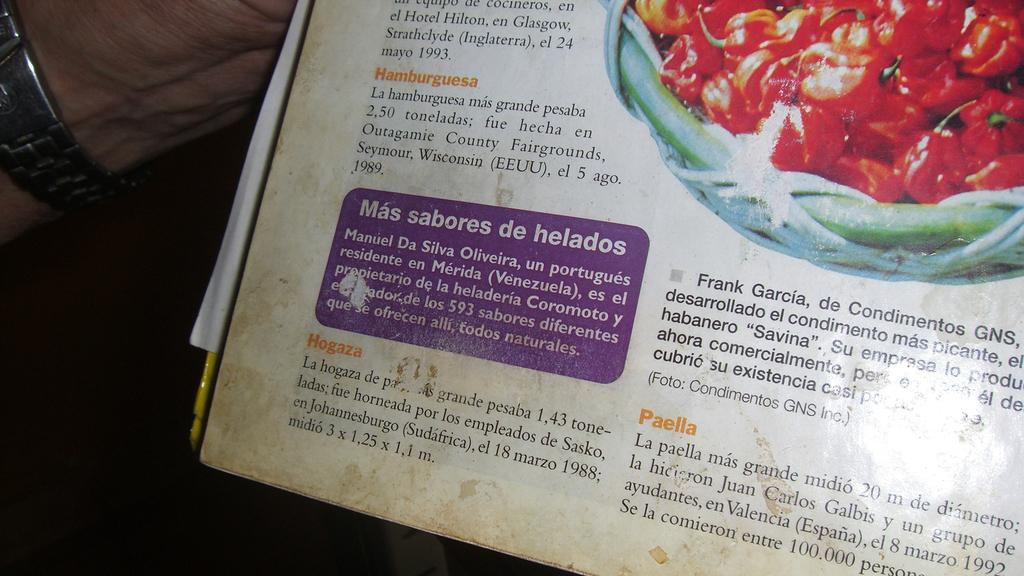<image>
Give a short and clear explanation of the subsequent image. A menu shows items in Spanish, one being Hamburguesa 